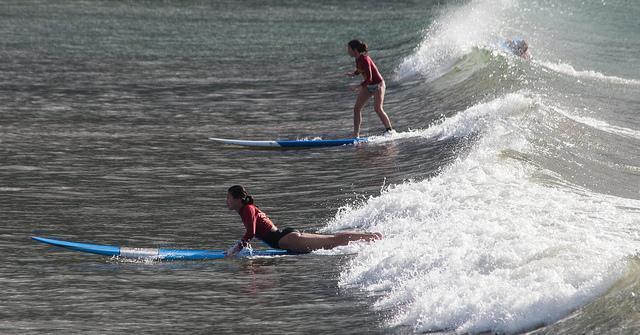How many humans are in the image?
Give a very brief answer. 3. How many orange slices can you see?
Give a very brief answer. 0. 